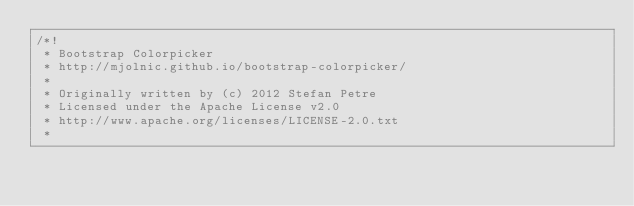Convert code to text. <code><loc_0><loc_0><loc_500><loc_500><_CSS_>/*!
 * Bootstrap Colorpicker
 * http://mjolnic.github.io/bootstrap-colorpicker/
 *
 * Originally written by (c) 2012 Stefan Petre
 * Licensed under the Apache License v2.0
 * http://www.apache.org/licenses/LICENSE-2.0.txt
 *</code> 